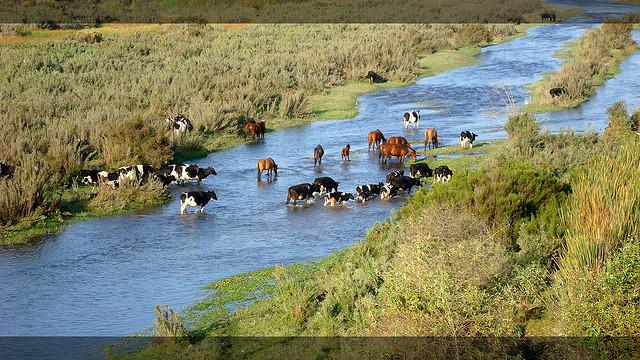Is this a cow baptism?
Concise answer only. No. Are there cows in the herd?
Answer briefly. Yes. What body of water are the animals in this picture bathing in?
Answer briefly. River. Are the animals swimming?
Keep it brief. No. 